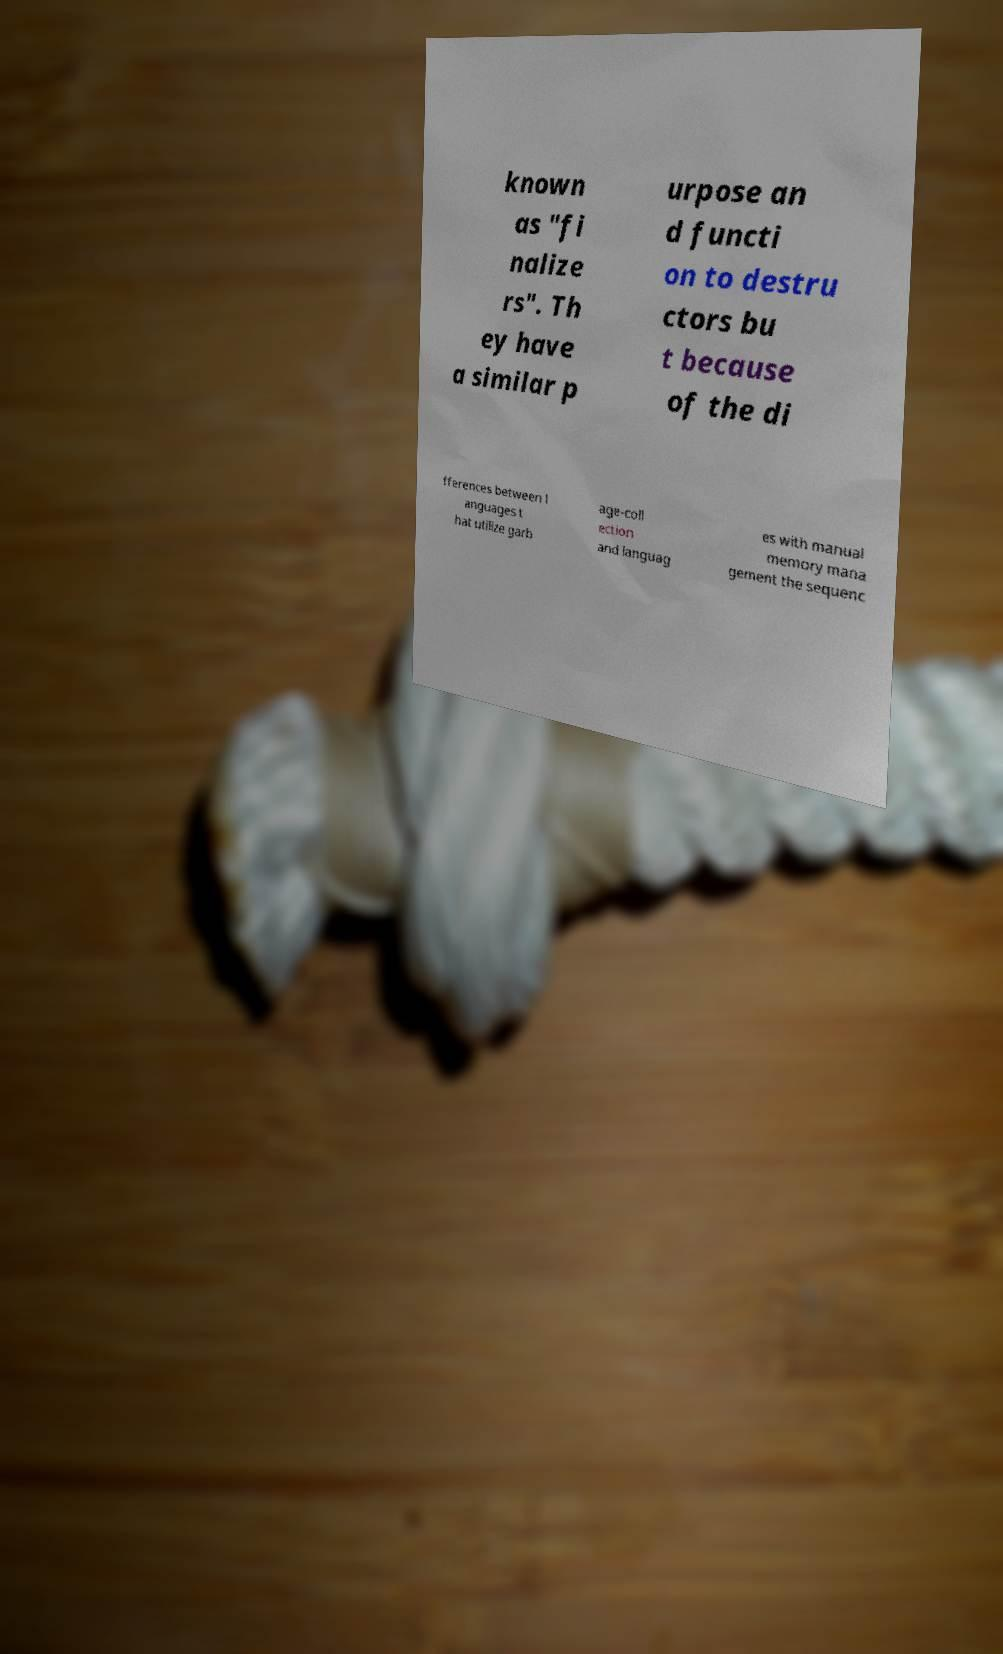Please identify and transcribe the text found in this image. known as "fi nalize rs". Th ey have a similar p urpose an d functi on to destru ctors bu t because of the di fferences between l anguages t hat utilize garb age-coll ection and languag es with manual memory mana gement the sequenc 